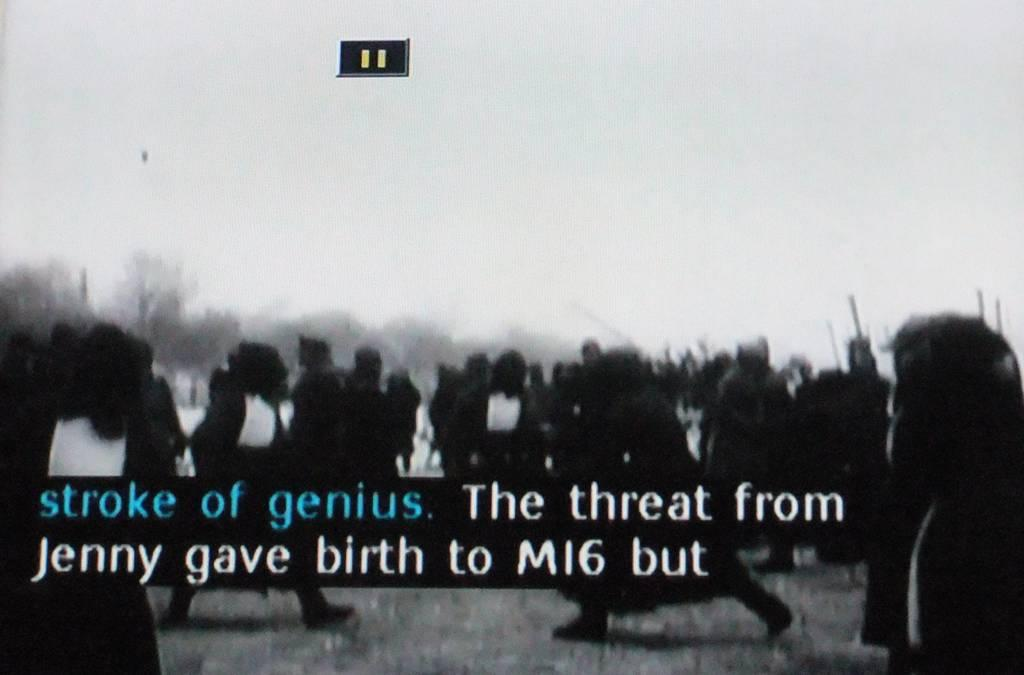What is the main subject of the image? The main subject of the image is a photo. What can be seen in the photo? The photo contains people. Is there any text present on the photo? Yes, there is text on the photo. What type of caption is written under the photo to describe the earthquake? There is no earthquake mentioned in the image, and no caption is visible under the photo. 